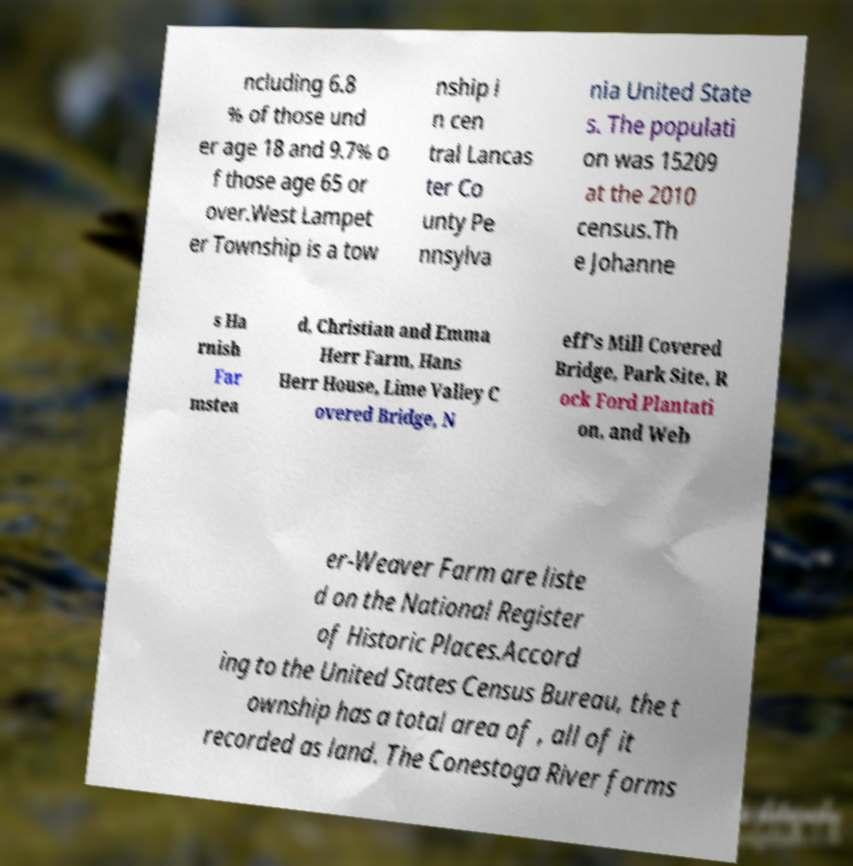Can you accurately transcribe the text from the provided image for me? ncluding 6.8 % of those und er age 18 and 9.7% o f those age 65 or over.West Lampet er Township is a tow nship i n cen tral Lancas ter Co unty Pe nnsylva nia United State s. The populati on was 15209 at the 2010 census.Th e Johanne s Ha rnish Far mstea d, Christian and Emma Herr Farm, Hans Herr House, Lime Valley C overed Bridge, N eff's Mill Covered Bridge, Park Site, R ock Ford Plantati on, and Web er-Weaver Farm are liste d on the National Register of Historic Places.Accord ing to the United States Census Bureau, the t ownship has a total area of , all of it recorded as land. The Conestoga River forms 